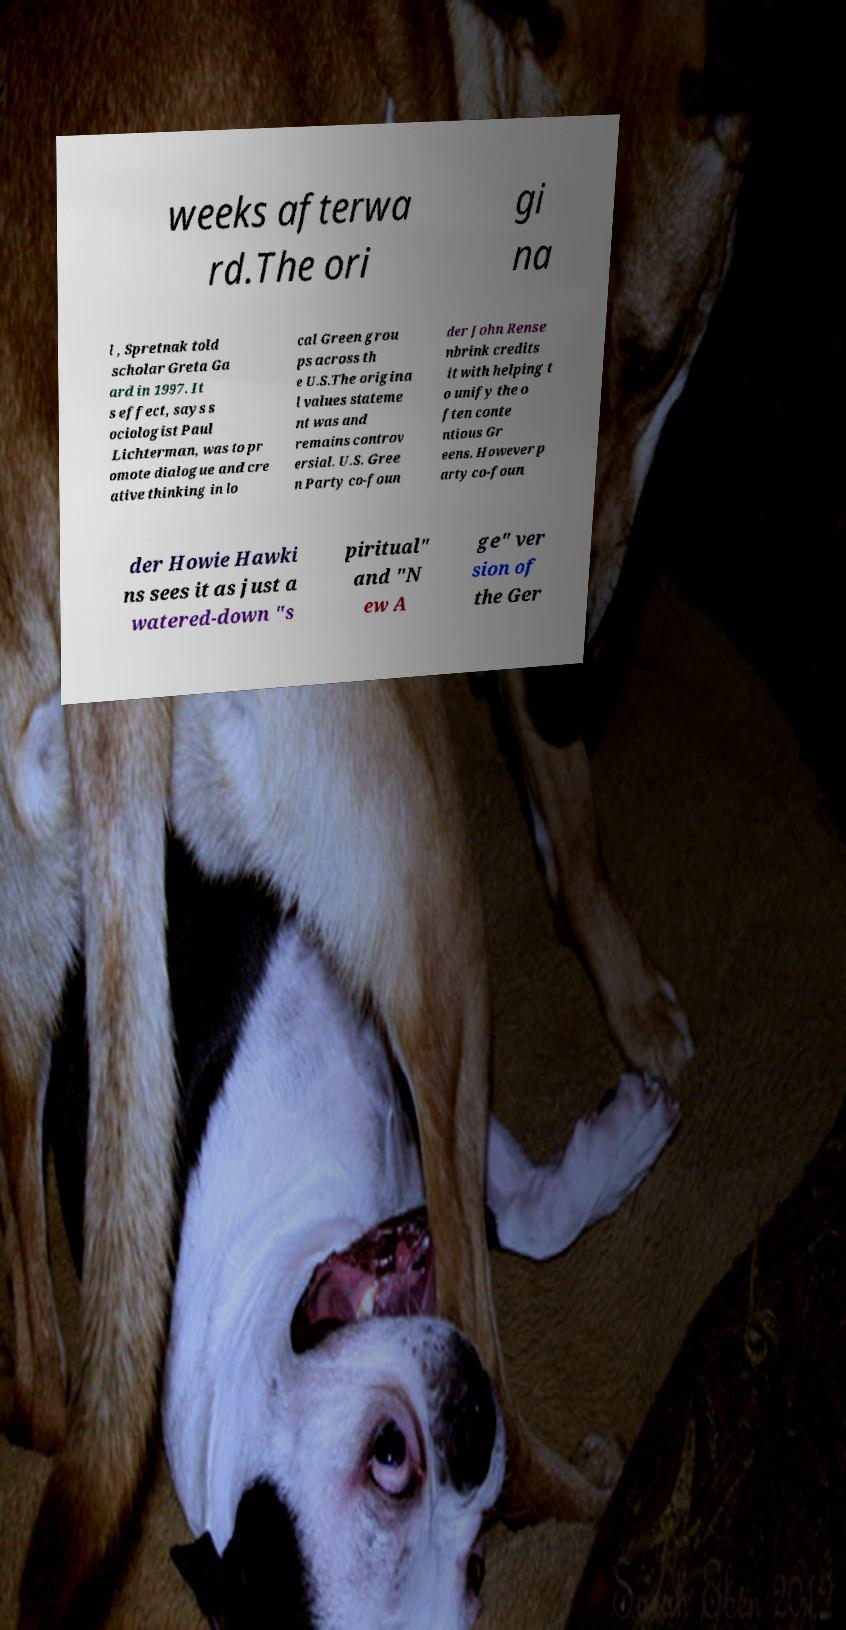Please identify and transcribe the text found in this image. weeks afterwa rd.The ori gi na l , Spretnak told scholar Greta Ga ard in 1997. It s effect, says s ociologist Paul Lichterman, was to pr omote dialogue and cre ative thinking in lo cal Green grou ps across th e U.S.The origina l values stateme nt was and remains controv ersial. U.S. Gree n Party co-foun der John Rense nbrink credits it with helping t o unify the o ften conte ntious Gr eens. However p arty co-foun der Howie Hawki ns sees it as just a watered-down "s piritual" and "N ew A ge" ver sion of the Ger 